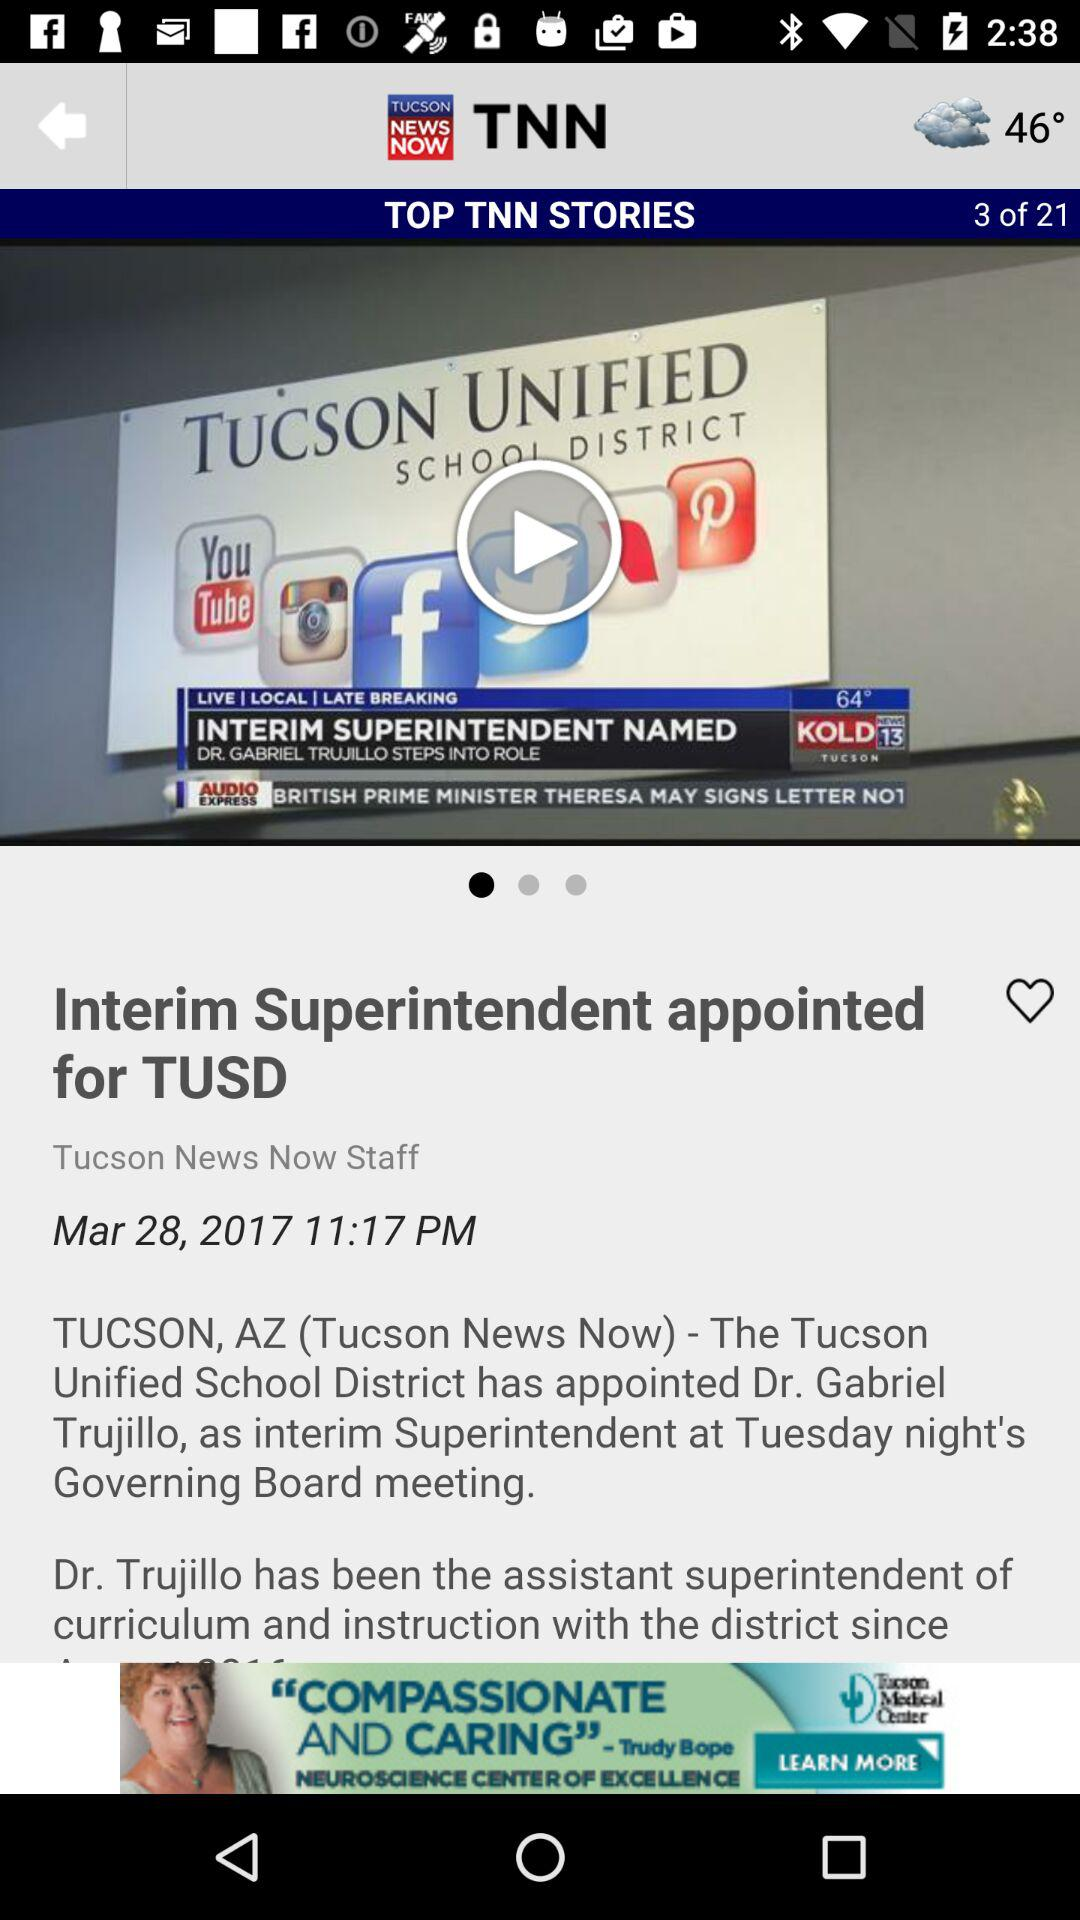What is the date of the news? The date is March 28, 2017. 